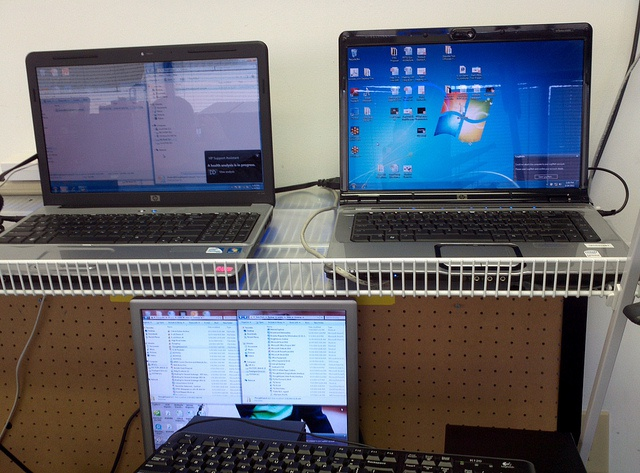Describe the objects in this image and their specific colors. I can see laptop in lightgray, black, gray, and darkgray tones, laptop in lightgray, lightblue, and gray tones, tv in lightgray, lightblue, and gray tones, keyboard in lightgray, black, gray, and darkgray tones, and keyboard in lightgray, black, gray, and darkgray tones in this image. 